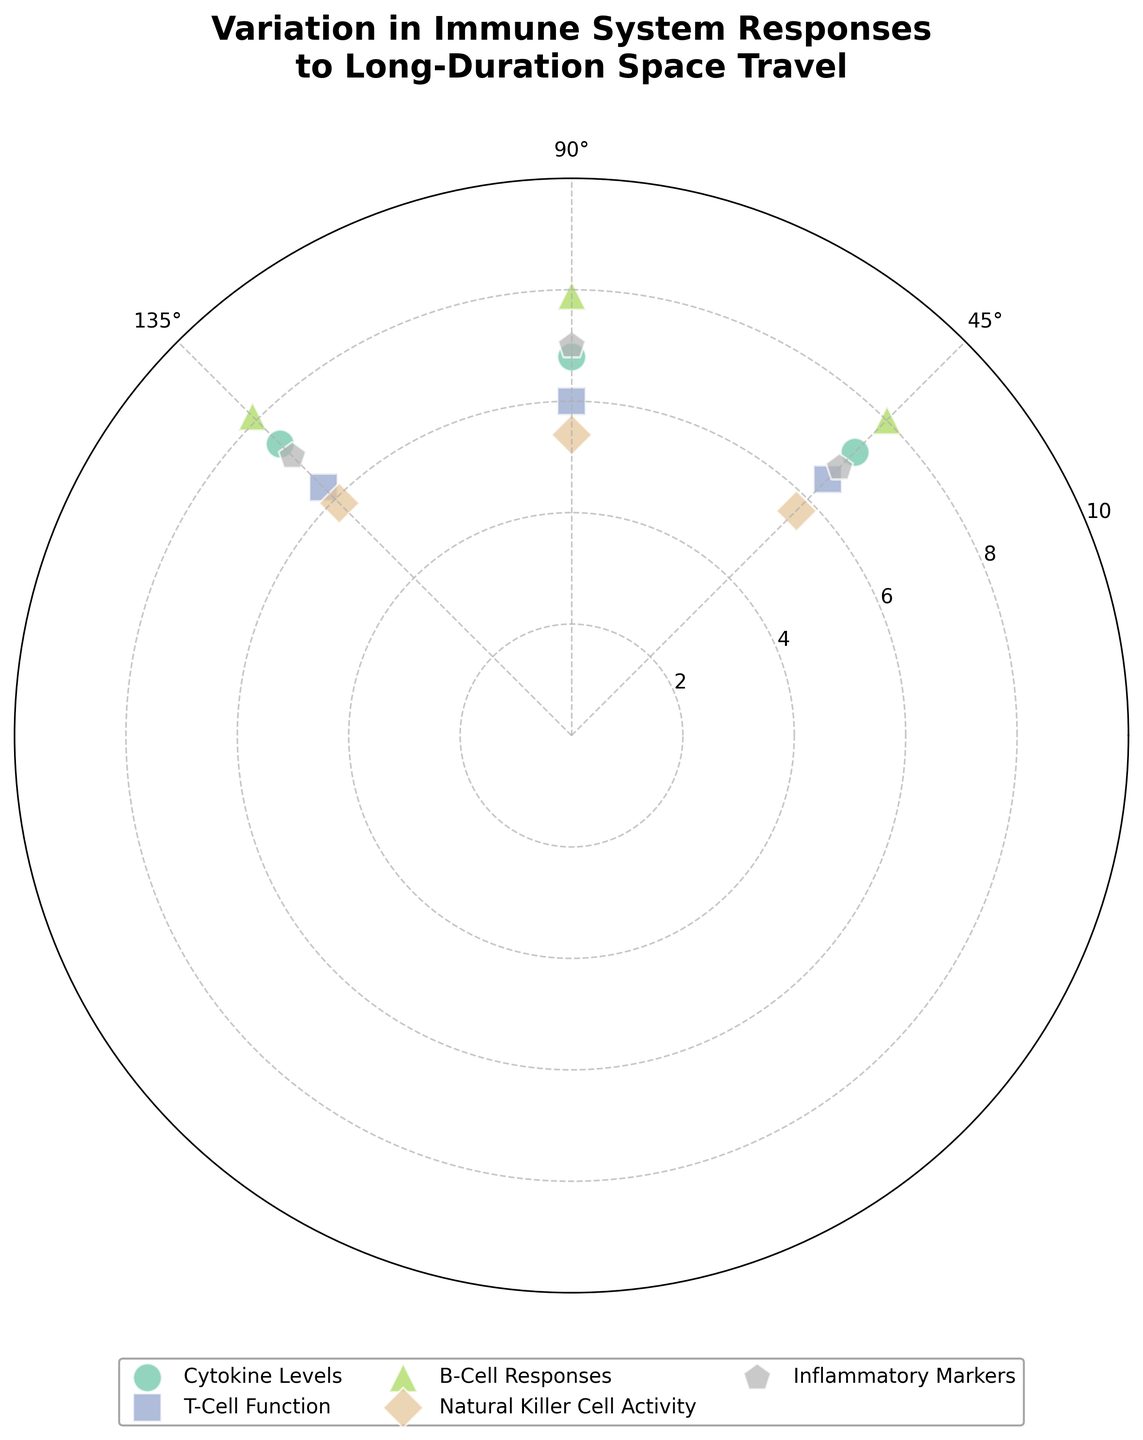What's the title of the figure? The title of the figure is usually found at the top and provides a summary of what the chart is about. Here, it states the main focus of the chart.
Answer: Variation in Immune System Responses to Long-Duration Space Travel How many categories are represented in the chart? The categories can be identified by different symbols or colors. Each category represents a different aspect of the immune system. By counting these, we find all unique categories present.
Answer: 5 Which immune response level is the highest, and what is its associated category and angle? By scanning all data points on the polar scatter chart, the point farthest from the center represents the highest immune response level. Note the category and angle associated with it.
Answer: 8.1, B-Cell Responses, 135° What is the average immune response level for the "Inflammatory Markers" category? To find the average immune response level, first, identify all data points under the "Inflammatory Markers" category. Add these values together and divide by the number of points.
Answer: (6.8 + 7.0 + 7.1) / 3 = 20.9 / 3 = 6.97 Which category shows the least variation in immune response levels? Variation can be assessed by looking at the spread of the data points within each category. The category with the smallest difference between its highest and lowest points has the least variation.
Answer: T-Cell Function Are there any categories that have higher immune response levels at 45 degrees compared to 90 degrees? Compare the immune response levels at these two angles for each category individually. Identify the categories where the value at 45 degrees is greater than at 90 degrees.
Answer: Cytokine Levels, Natural Killer Cell Activity, Inflammatory Markers What is the difference in immune response levels for "Natural Killer Cell Activity" between 45 degrees and 135 degrees? Subtract the response level at 45 degrees from that at 135 degrees for this specific category.
Answer: 5.9 - 5.7 = 0.2 Which category has the highest immune response level consistently across all angles? For each category, compare the immune response levels at all angles. Identify which category has high values across all measured points without significant dips.
Answer: B-Cell Responses What can be inferred about T-Cell Function compared to Cytokine Levels at 90 degrees? Look at the immune response levels for both categories at the 90 degrees mark and compare their values to make a conclusion.
Answer: Cytokine Levels are higher than T-Cell Function at 90 degrees (6.8 vs. 6.0) What is the median immune response level for all data points combined? Combine all the immune response levels from every category and sort them. The median is the middle value in this sorted list.
Answer: 6.8 